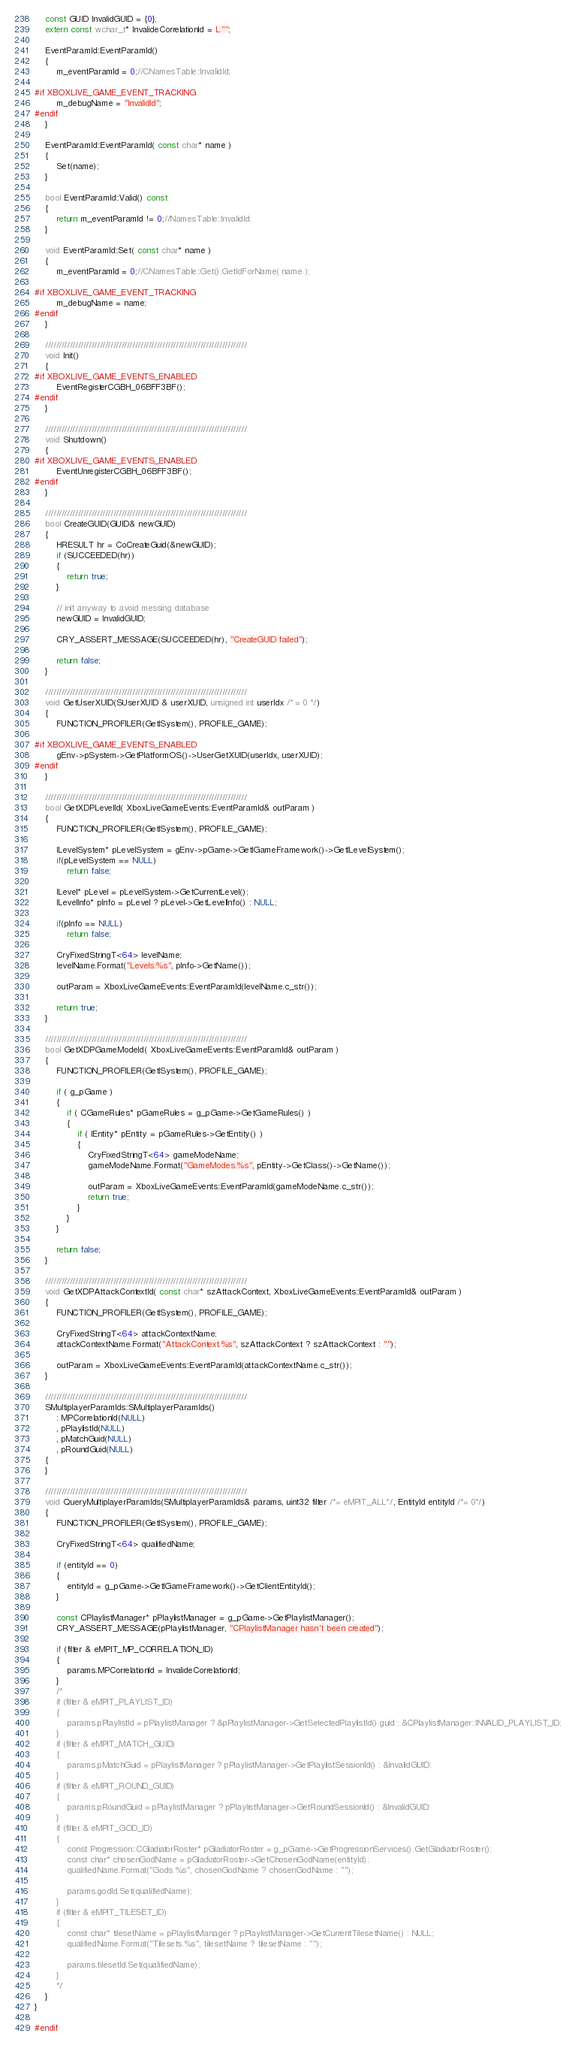Convert code to text. <code><loc_0><loc_0><loc_500><loc_500><_C++_>	const GUID InvalidGUID = {0};
	extern const wchar_t* InvalideCorrelationId = L"";

	EventParamId::EventParamId()
	{
		m_eventParamId = 0;//CNamesTable::InvalidId;

#if XBOXLIVE_GAME_EVENT_TRACKING
		m_debugName = "InvalidId";
#endif
	}

	EventParamId::EventParamId( const char* name )
	{
		Set(name);
	}

	bool EventParamId::Valid() const
	{
		return m_eventParamId != 0;//NamesTable::InvalidId;
	}

	void EventParamId::Set( const char* name )
	{
		m_eventParamId = 0;//CNamesTable::Get().GetIdForName( name );		

#if XBOXLIVE_GAME_EVENT_TRACKING
		m_debugName = name;
#endif
	}

	//////////////////////////////////////////////////////////////////////////
	void Init()
	{
#if XBOXLIVE_GAME_EVENTS_ENABLED
		EventRegisterCGBH_06BFF3BF();
#endif
	}

	//////////////////////////////////////////////////////////////////////////
	void Shutdown()
	{
#if XBOXLIVE_GAME_EVENTS_ENABLED
		EventUnregisterCGBH_06BFF3BF();
#endif
	}

	//////////////////////////////////////////////////////////////////////////
	bool CreateGUID(GUID& newGUID)
	{
		HRESULT hr = CoCreateGuid(&newGUID);
		if (SUCCEEDED(hr))
		{
			return true;
		}

		// init anyway to avoid messing database
		newGUID = InvalidGUID;

		CRY_ASSERT_MESSAGE(SUCCEEDED(hr), "CreateGUID failed");

		return false;
	}

	//////////////////////////////////////////////////////////////////////////
	void GetUserXUID(SUserXUID & userXUID, unsigned int userIdx /* = 0 */)
	{
		FUNCTION_PROFILER(GetISystem(), PROFILE_GAME);

#if XBOXLIVE_GAME_EVENTS_ENABLED
		gEnv->pSystem->GetPlatformOS()->UserGetXUID(userIdx, userXUID);
#endif
	}

	//////////////////////////////////////////////////////////////////////////
	bool GetXDPLevelId( XboxLiveGameEvents::EventParamId& outParam )
	{
		FUNCTION_PROFILER(GetISystem(), PROFILE_GAME);

		ILevelSystem* pLevelSystem = gEnv->pGame->GetIGameFramework()->GetILevelSystem();
		if(pLevelSystem == NULL)
			return false;

		ILevel* pLevel = pLevelSystem->GetCurrentLevel();
		ILevelInfo* pInfo = pLevel ? pLevel->GetLevelInfo() : NULL;

		if(pInfo == NULL)
			return false;

		CryFixedStringT<64> levelName;
		levelName.Format("Levels.%s", pInfo->GetName());

		outParam = XboxLiveGameEvents::EventParamId(levelName.c_str());

		return true;
	}

	//////////////////////////////////////////////////////////////////////////
	bool GetXDPGameModeId( XboxLiveGameEvents::EventParamId& outParam )
	{
		FUNCTION_PROFILER(GetISystem(), PROFILE_GAME);

		if ( g_pGame )
		{
			if ( CGameRules* pGameRules = g_pGame->GetGameRules() )
			{
				if ( IEntity* pEntity = pGameRules->GetEntity() )
				{
					CryFixedStringT<64> gameModeName;
					gameModeName.Format("GameModes.%s", pEntity->GetClass()->GetName());

					outParam = XboxLiveGameEvents::EventParamId(gameModeName.c_str());
					return true;
				}
			}
		}

		return false;
	}

	//////////////////////////////////////////////////////////////////////////
	void GetXDPAttackContextId( const char* szAttackContext, XboxLiveGameEvents::EventParamId& outParam )
	{
		FUNCTION_PROFILER(GetISystem(), PROFILE_GAME);

		CryFixedStringT<64> attackContextName;
		attackContextName.Format("AttackContext.%s", szAttackContext ? szAttackContext : "");

		outParam = XboxLiveGameEvents::EventParamId(attackContextName.c_str());
	}

	//////////////////////////////////////////////////////////////////////////
	SMultiplayerParamIds::SMultiplayerParamIds()
		: MPCorrelationId(NULL)
		, pPlaylistId(NULL)
		, pMatchGuid(NULL)
		, pRoundGuid(NULL)
	{
	}

	//////////////////////////////////////////////////////////////////////////
	void QueryMultiplayerParamIds(SMultiplayerParamIds& params, uint32 filter /*= eMPIT_ALL*/, EntityId entityId /*= 0*/)
	{
		FUNCTION_PROFILER(GetISystem(), PROFILE_GAME);

		CryFixedStringT<64> qualifiedName;

		if (entityId == 0)
		{
			entityId = g_pGame->GetIGameFramework()->GetClientEntityId();
		}

		const CPlaylistManager* pPlaylistManager = g_pGame->GetPlaylistManager();
		CRY_ASSERT_MESSAGE(pPlaylistManager, "CPlaylistManager hasn't been created");

		if (filter & eMPIT_MP_CORRELATION_ID)
		{
			params.MPCorrelationId = InvalideCorrelationId;
		}
		/*
		if (filter & eMPIT_PLAYLIST_ID)
		{
			params.pPlaylistId = pPlaylistManager ? &pPlaylistManager->GetSelectedPlaylistId().guid : &CPlaylistManager::INVALID_PLAYLIST_ID;
		}
		if (filter & eMPIT_MATCH_GUID)
		{
			params.pMatchGuid = pPlaylistManager ? pPlaylistManager->GetPlaylistSessionId() : &InvalidGUID;
		}
		if (filter & eMPIT_ROUND_GUID)
		{
			params.pRoundGuid = pPlaylistManager ? pPlaylistManager->GetRoundSessionId() : &InvalidGUID;
		}
		if (filter & eMPIT_GOD_ID)
		{
			const Progression::CGladiatorRoster* pGladiatorRoster = g_pGame->GetProgressionServices().GetGladiatorRoster();
			const char* chosenGodName = pGladiatorRoster->GetChosenGodName(entityId);
			qualifiedName.Format("Gods.%s", chosenGodName ? chosenGodName : "");

			params.godId.Set(qualifiedName);
		}
		if (filter & eMPIT_TILESET_ID)
		{
			const char* tilesetName = pPlaylistManager ? pPlaylistManager->GetCurrentTilesetName() : NULL;
			qualifiedName.Format("Tilesets.%s", tilesetName ? tilesetName : "");

			params.tilesetId.Set(qualifiedName);
		}
		*/
	}
}

#endif</code> 